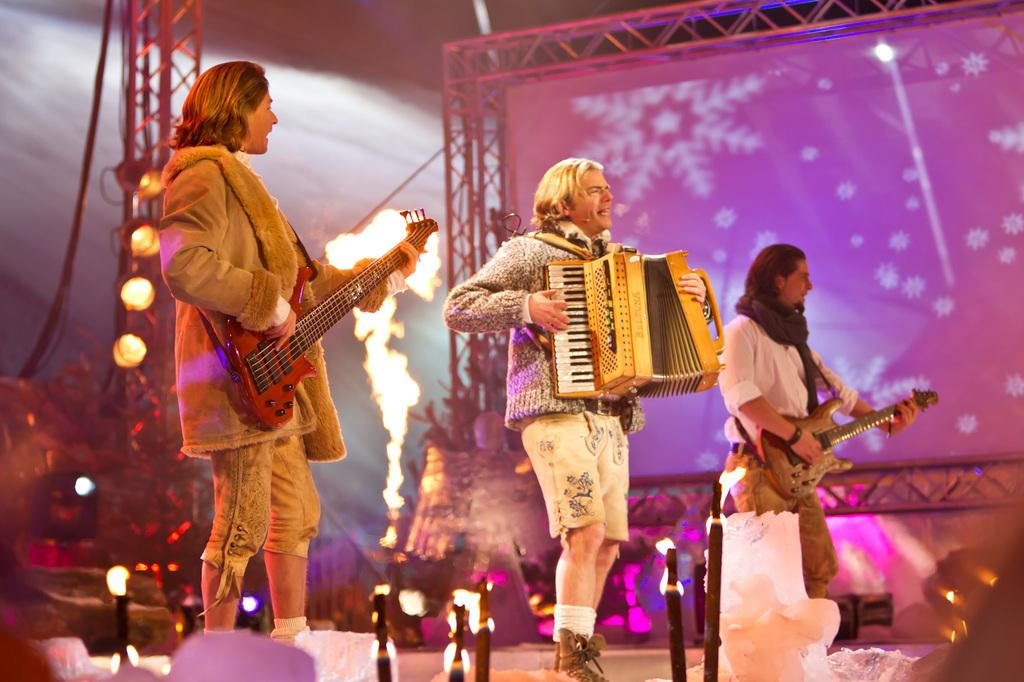How many people are performing in the image? There are three people in the image. What are the people doing on the stage? The people are performing on a stage. What instrument is one of the people playing? One of the people is playing a guitar. What are the other two people doing while performing? The other two people are singing into microphones. What type of territory is being claimed by the people in the image? There is no indication in the image that the people are claiming any territory. Can you see any gloves being used by the performers in the image? There are no gloves visible in the image; the people are using a guitar and microphones. 